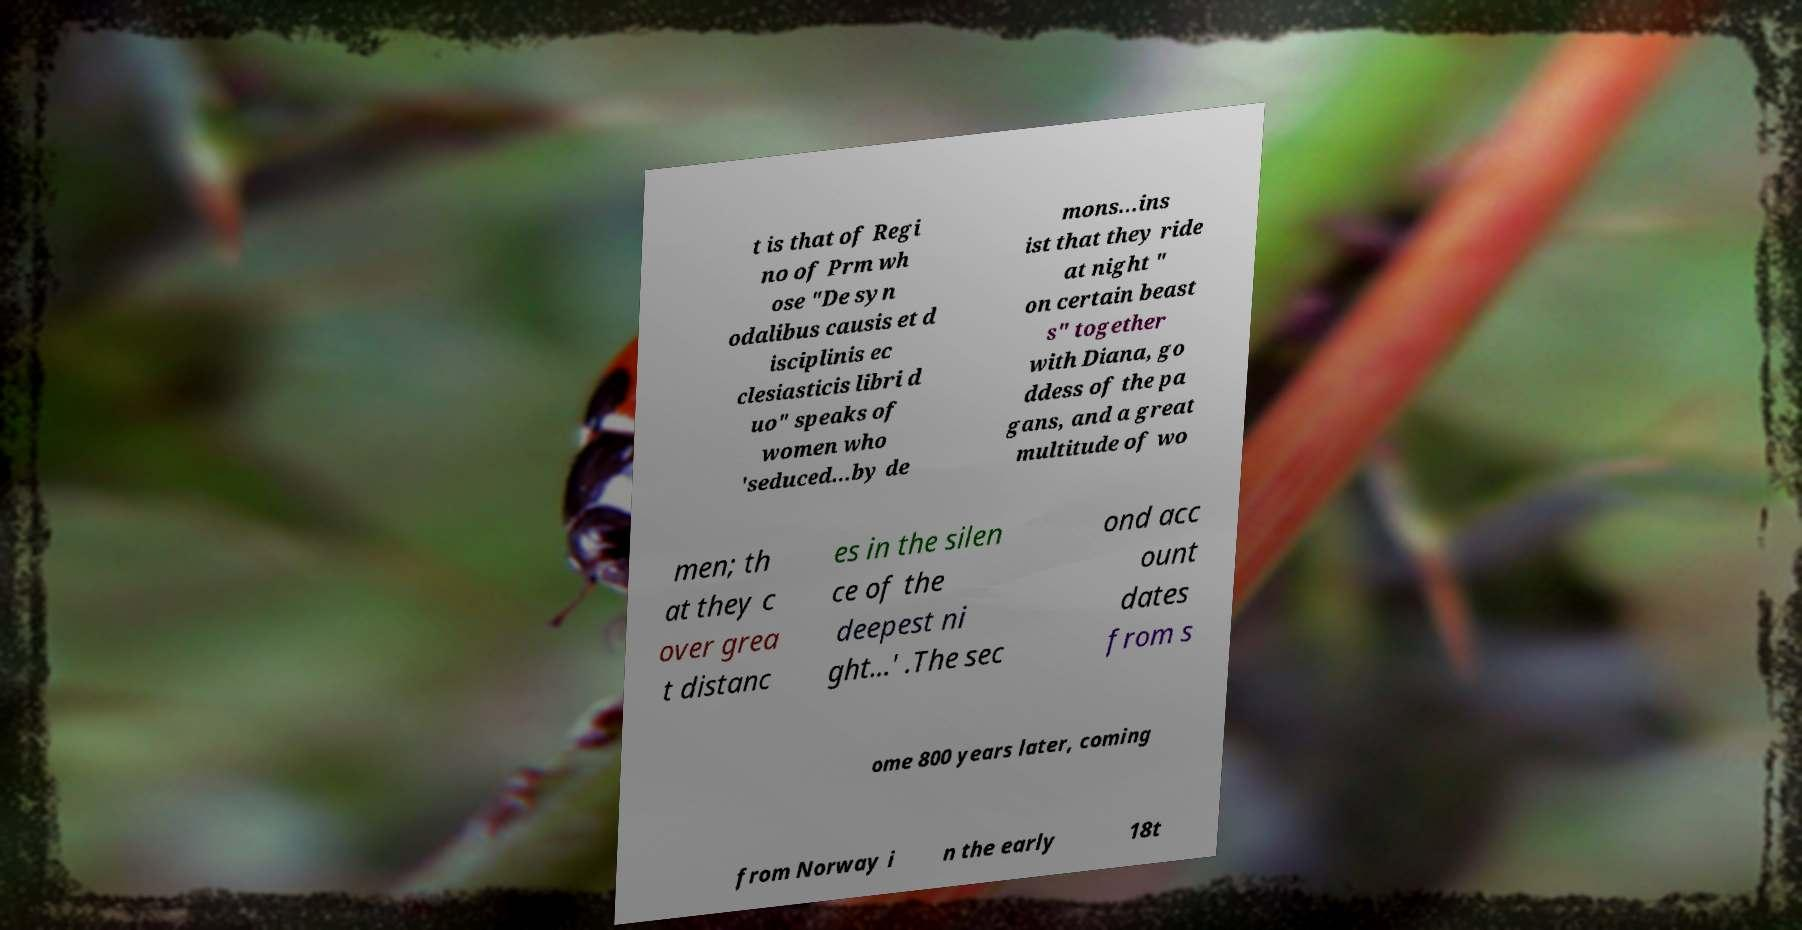What messages or text are displayed in this image? I need them in a readable, typed format. t is that of Regi no of Prm wh ose "De syn odalibus causis et d isciplinis ec clesiasticis libri d uo" speaks of women who 'seduced...by de mons...ins ist that they ride at night " on certain beast s" together with Diana, go ddess of the pa gans, and a great multitude of wo men; th at they c over grea t distanc es in the silen ce of the deepest ni ght...' .The sec ond acc ount dates from s ome 800 years later, coming from Norway i n the early 18t 